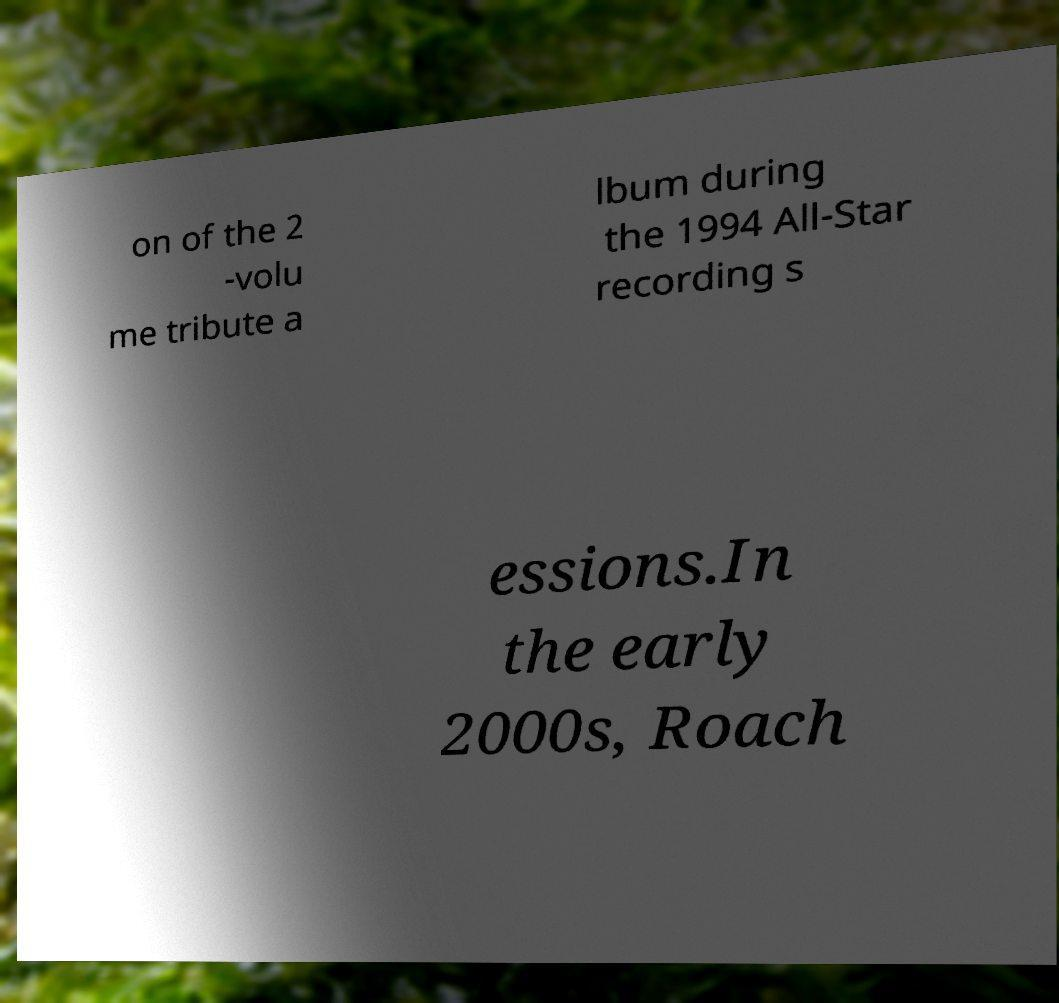There's text embedded in this image that I need extracted. Can you transcribe it verbatim? on of the 2 -volu me tribute a lbum during the 1994 All-Star recording s essions.In the early 2000s, Roach 